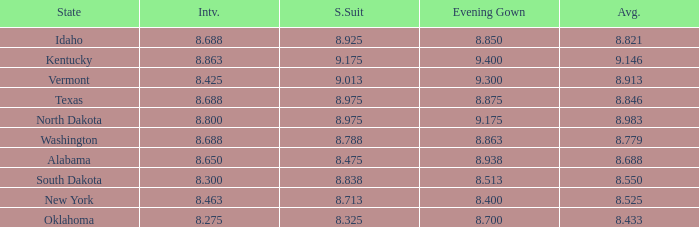What is the highest average of the contestant from Texas with an evening gown larger than 8.875? None. Could you parse the entire table as a dict? {'header': ['State', 'Intv.', 'S.Suit', 'Evening Gown', 'Avg.'], 'rows': [['Idaho', '8.688', '8.925', '8.850', '8.821'], ['Kentucky', '8.863', '9.175', '9.400', '9.146'], ['Vermont', '8.425', '9.013', '9.300', '8.913'], ['Texas', '8.688', '8.975', '8.875', '8.846'], ['North Dakota', '8.800', '8.975', '9.175', '8.983'], ['Washington', '8.688', '8.788', '8.863', '8.779'], ['Alabama', '8.650', '8.475', '8.938', '8.688'], ['South Dakota', '8.300', '8.838', '8.513', '8.550'], ['New York', '8.463', '8.713', '8.400', '8.525'], ['Oklahoma', '8.275', '8.325', '8.700', '8.433']]} 